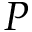<formula> <loc_0><loc_0><loc_500><loc_500>P</formula> 